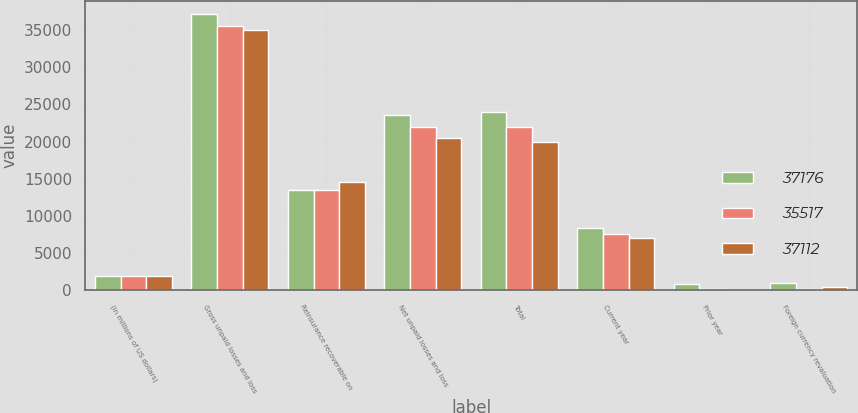<chart> <loc_0><loc_0><loc_500><loc_500><stacked_bar_chart><ecel><fcel>(in millions of US dollars)<fcel>Gross unpaid losses and loss<fcel>Reinsurance recoverable on<fcel>Net unpaid losses and loss<fcel>Total<fcel>Current year<fcel>Prior year<fcel>Foreign currency revaluation<nl><fcel>37176<fcel>2008<fcel>37112<fcel>13520<fcel>23592<fcel>23945<fcel>8417<fcel>814<fcel>980<nl><fcel>35517<fcel>2007<fcel>35517<fcel>13509<fcel>22008<fcel>22008<fcel>7568<fcel>217<fcel>167<nl><fcel>37112<fcel>2006<fcel>35055<fcel>14597<fcel>20458<fcel>19986<fcel>7082<fcel>12<fcel>411<nl></chart> 